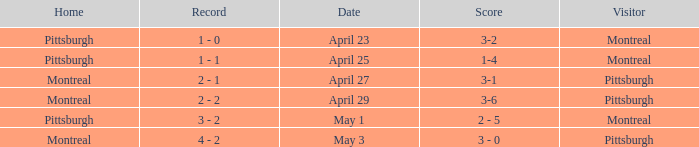When did Montreal visit and have a score of 1-4? April 25. 